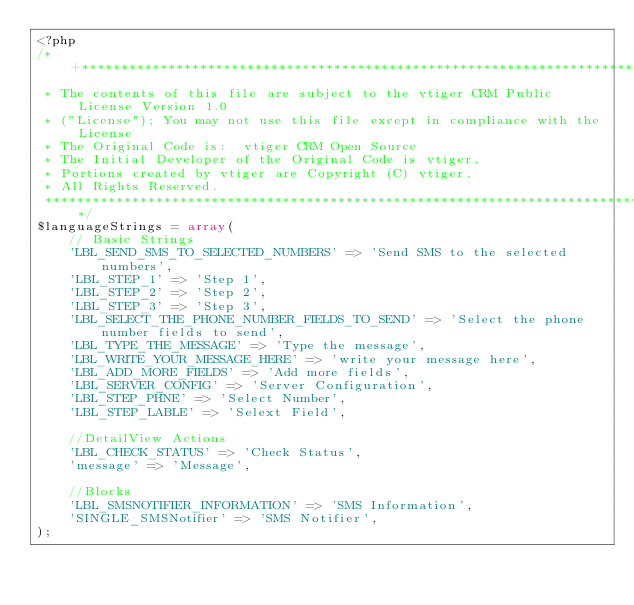Convert code to text. <code><loc_0><loc_0><loc_500><loc_500><_PHP_><?php
/*+***********************************************************************************
 * The contents of this file are subject to the vtiger CRM Public License Version 1.0
 * ("License"); You may not use this file except in compliance with the License
 * The Original Code is:  vtiger CRM Open Source
 * The Initial Developer of the Original Code is vtiger.
 * Portions created by vtiger are Copyright (C) vtiger.
 * All Rights Reserved.
 *************************************************************************************/
$languageStrings = array(
	// Basic Strings
	'LBL_SEND_SMS_TO_SELECTED_NUMBERS' => 'Send SMS to the selected numbers',
	'LBL_STEP_1' => 'Step 1',
	'LBL_STEP_2' => 'Step 2',
	'LBL_STEP_3' => 'Step 3',
	'LBL_SELECT_THE_PHONE_NUMBER_FIELDS_TO_SEND' => 'Select the phone number fields to send',
	'LBL_TYPE_THE_MESSAGE' => 'Type the message',
	'LBL_WRITE_YOUR_MESSAGE_HERE' => 'write your message here',
	'LBL_ADD_MORE_FIELDS' => 'Add more fields',
	'LBL_SERVER_CONFIG' => 'Server Configuration',
	'LBL_STEP_PHNE' => 'Select Number',
	'LBL_STEP_LABLE' => 'Selext Field',

	//DetailView Actions
	'LBL_CHECK_STATUS' => 'Check Status',
	'message' => 'Message',

	//Blocks
	'LBL_SMSNOTIFIER_INFORMATION' => 'SMS Information',
	'SINGLE_SMSNotifier' => 'SMS Notifier',
);
</code> 